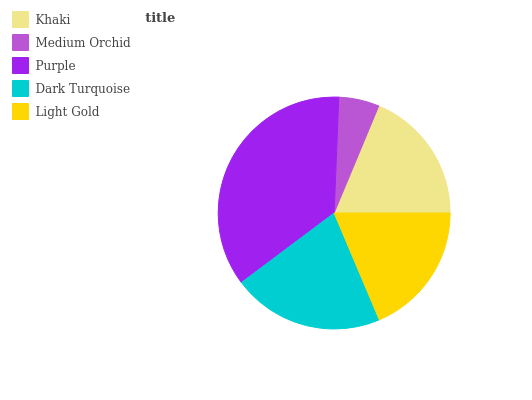Is Medium Orchid the minimum?
Answer yes or no. Yes. Is Purple the maximum?
Answer yes or no. Yes. Is Purple the minimum?
Answer yes or no. No. Is Medium Orchid the maximum?
Answer yes or no. No. Is Purple greater than Medium Orchid?
Answer yes or no. Yes. Is Medium Orchid less than Purple?
Answer yes or no. Yes. Is Medium Orchid greater than Purple?
Answer yes or no. No. Is Purple less than Medium Orchid?
Answer yes or no. No. Is Khaki the high median?
Answer yes or no. Yes. Is Khaki the low median?
Answer yes or no. Yes. Is Purple the high median?
Answer yes or no. No. Is Purple the low median?
Answer yes or no. No. 